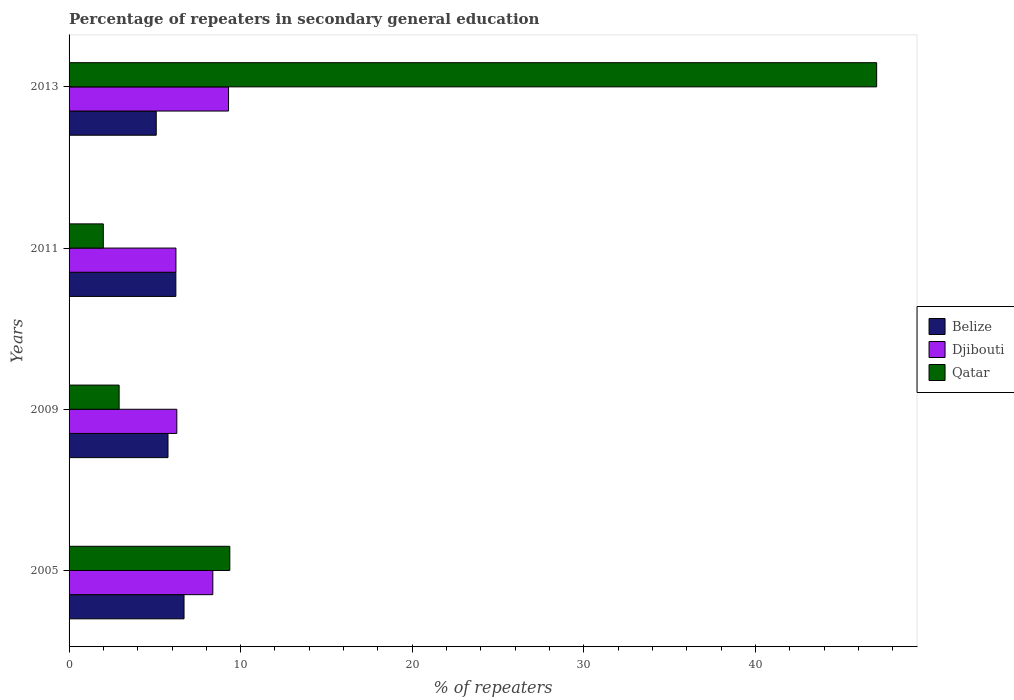How many groups of bars are there?
Your response must be concise. 4. Are the number of bars on each tick of the Y-axis equal?
Give a very brief answer. Yes. How many bars are there on the 1st tick from the bottom?
Offer a very short reply. 3. What is the percentage of repeaters in secondary general education in Belize in 2011?
Your answer should be compact. 6.22. Across all years, what is the maximum percentage of repeaters in secondary general education in Belize?
Provide a succinct answer. 6.7. Across all years, what is the minimum percentage of repeaters in secondary general education in Qatar?
Provide a succinct answer. 1.99. In which year was the percentage of repeaters in secondary general education in Qatar maximum?
Offer a terse response. 2013. In which year was the percentage of repeaters in secondary general education in Belize minimum?
Offer a very short reply. 2013. What is the total percentage of repeaters in secondary general education in Djibouti in the graph?
Your answer should be compact. 30.18. What is the difference between the percentage of repeaters in secondary general education in Djibouti in 2005 and that in 2011?
Your answer should be very brief. 2.15. What is the difference between the percentage of repeaters in secondary general education in Belize in 2011 and the percentage of repeaters in secondary general education in Qatar in 2013?
Provide a short and direct response. -40.84. What is the average percentage of repeaters in secondary general education in Qatar per year?
Your answer should be very brief. 15.34. In the year 2009, what is the difference between the percentage of repeaters in secondary general education in Qatar and percentage of repeaters in secondary general education in Djibouti?
Your response must be concise. -3.36. In how many years, is the percentage of repeaters in secondary general education in Qatar greater than 14 %?
Your response must be concise. 1. What is the ratio of the percentage of repeaters in secondary general education in Djibouti in 2011 to that in 2013?
Give a very brief answer. 0.67. What is the difference between the highest and the second highest percentage of repeaters in secondary general education in Belize?
Keep it short and to the point. 0.48. What is the difference between the highest and the lowest percentage of repeaters in secondary general education in Belize?
Provide a succinct answer. 1.62. What does the 3rd bar from the top in 2013 represents?
Provide a short and direct response. Belize. What does the 2nd bar from the bottom in 2011 represents?
Your answer should be compact. Djibouti. Is it the case that in every year, the sum of the percentage of repeaters in secondary general education in Belize and percentage of repeaters in secondary general education in Qatar is greater than the percentage of repeaters in secondary general education in Djibouti?
Provide a short and direct response. Yes. How many years are there in the graph?
Your response must be concise. 4. Does the graph contain any zero values?
Offer a very short reply. No. What is the title of the graph?
Your answer should be very brief. Percentage of repeaters in secondary general education. What is the label or title of the X-axis?
Your response must be concise. % of repeaters. What is the label or title of the Y-axis?
Provide a short and direct response. Years. What is the % of repeaters in Belize in 2005?
Give a very brief answer. 6.7. What is the % of repeaters of Djibouti in 2005?
Your answer should be very brief. 8.38. What is the % of repeaters in Qatar in 2005?
Provide a short and direct response. 9.37. What is the % of repeaters of Belize in 2009?
Your response must be concise. 5.77. What is the % of repeaters of Djibouti in 2009?
Give a very brief answer. 6.28. What is the % of repeaters in Qatar in 2009?
Your response must be concise. 2.92. What is the % of repeaters in Belize in 2011?
Your answer should be very brief. 6.22. What is the % of repeaters in Djibouti in 2011?
Your answer should be very brief. 6.23. What is the % of repeaters of Qatar in 2011?
Make the answer very short. 1.99. What is the % of repeaters in Belize in 2013?
Provide a short and direct response. 5.08. What is the % of repeaters in Djibouti in 2013?
Provide a short and direct response. 9.29. What is the % of repeaters in Qatar in 2013?
Ensure brevity in your answer.  47.07. Across all years, what is the maximum % of repeaters of Belize?
Keep it short and to the point. 6.7. Across all years, what is the maximum % of repeaters of Djibouti?
Your answer should be compact. 9.29. Across all years, what is the maximum % of repeaters of Qatar?
Provide a short and direct response. 47.07. Across all years, what is the minimum % of repeaters in Belize?
Offer a very short reply. 5.08. Across all years, what is the minimum % of repeaters in Djibouti?
Offer a very short reply. 6.23. Across all years, what is the minimum % of repeaters in Qatar?
Give a very brief answer. 1.99. What is the total % of repeaters of Belize in the graph?
Your answer should be very brief. 23.77. What is the total % of repeaters in Djibouti in the graph?
Provide a short and direct response. 30.18. What is the total % of repeaters of Qatar in the graph?
Give a very brief answer. 61.35. What is the difference between the % of repeaters of Belize in 2005 and that in 2009?
Ensure brevity in your answer.  0.93. What is the difference between the % of repeaters of Djibouti in 2005 and that in 2009?
Your answer should be compact. 2.1. What is the difference between the % of repeaters of Qatar in 2005 and that in 2009?
Your answer should be very brief. 6.45. What is the difference between the % of repeaters in Belize in 2005 and that in 2011?
Provide a short and direct response. 0.48. What is the difference between the % of repeaters of Djibouti in 2005 and that in 2011?
Make the answer very short. 2.15. What is the difference between the % of repeaters of Qatar in 2005 and that in 2011?
Your answer should be compact. 7.37. What is the difference between the % of repeaters of Belize in 2005 and that in 2013?
Provide a short and direct response. 1.62. What is the difference between the % of repeaters of Djibouti in 2005 and that in 2013?
Provide a succinct answer. -0.92. What is the difference between the % of repeaters in Qatar in 2005 and that in 2013?
Make the answer very short. -37.7. What is the difference between the % of repeaters of Belize in 2009 and that in 2011?
Keep it short and to the point. -0.46. What is the difference between the % of repeaters in Djibouti in 2009 and that in 2011?
Keep it short and to the point. 0.05. What is the difference between the % of repeaters of Qatar in 2009 and that in 2011?
Ensure brevity in your answer.  0.92. What is the difference between the % of repeaters in Belize in 2009 and that in 2013?
Keep it short and to the point. 0.69. What is the difference between the % of repeaters in Djibouti in 2009 and that in 2013?
Provide a short and direct response. -3.01. What is the difference between the % of repeaters of Qatar in 2009 and that in 2013?
Offer a very short reply. -44.15. What is the difference between the % of repeaters in Belize in 2011 and that in 2013?
Give a very brief answer. 1.14. What is the difference between the % of repeaters of Djibouti in 2011 and that in 2013?
Provide a short and direct response. -3.07. What is the difference between the % of repeaters of Qatar in 2011 and that in 2013?
Offer a very short reply. -45.07. What is the difference between the % of repeaters in Belize in 2005 and the % of repeaters in Djibouti in 2009?
Your answer should be compact. 0.42. What is the difference between the % of repeaters in Belize in 2005 and the % of repeaters in Qatar in 2009?
Keep it short and to the point. 3.78. What is the difference between the % of repeaters in Djibouti in 2005 and the % of repeaters in Qatar in 2009?
Offer a terse response. 5.46. What is the difference between the % of repeaters in Belize in 2005 and the % of repeaters in Djibouti in 2011?
Offer a terse response. 0.47. What is the difference between the % of repeaters in Belize in 2005 and the % of repeaters in Qatar in 2011?
Your answer should be compact. 4.71. What is the difference between the % of repeaters of Djibouti in 2005 and the % of repeaters of Qatar in 2011?
Ensure brevity in your answer.  6.38. What is the difference between the % of repeaters in Belize in 2005 and the % of repeaters in Djibouti in 2013?
Offer a very short reply. -2.59. What is the difference between the % of repeaters of Belize in 2005 and the % of repeaters of Qatar in 2013?
Provide a succinct answer. -40.37. What is the difference between the % of repeaters of Djibouti in 2005 and the % of repeaters of Qatar in 2013?
Give a very brief answer. -38.69. What is the difference between the % of repeaters of Belize in 2009 and the % of repeaters of Djibouti in 2011?
Offer a terse response. -0.46. What is the difference between the % of repeaters in Belize in 2009 and the % of repeaters in Qatar in 2011?
Offer a terse response. 3.77. What is the difference between the % of repeaters of Djibouti in 2009 and the % of repeaters of Qatar in 2011?
Keep it short and to the point. 4.29. What is the difference between the % of repeaters in Belize in 2009 and the % of repeaters in Djibouti in 2013?
Provide a short and direct response. -3.53. What is the difference between the % of repeaters in Belize in 2009 and the % of repeaters in Qatar in 2013?
Keep it short and to the point. -41.3. What is the difference between the % of repeaters in Djibouti in 2009 and the % of repeaters in Qatar in 2013?
Provide a short and direct response. -40.79. What is the difference between the % of repeaters of Belize in 2011 and the % of repeaters of Djibouti in 2013?
Ensure brevity in your answer.  -3.07. What is the difference between the % of repeaters in Belize in 2011 and the % of repeaters in Qatar in 2013?
Keep it short and to the point. -40.84. What is the difference between the % of repeaters in Djibouti in 2011 and the % of repeaters in Qatar in 2013?
Make the answer very short. -40.84. What is the average % of repeaters of Belize per year?
Ensure brevity in your answer.  5.94. What is the average % of repeaters in Djibouti per year?
Provide a short and direct response. 7.55. What is the average % of repeaters of Qatar per year?
Offer a very short reply. 15.34. In the year 2005, what is the difference between the % of repeaters in Belize and % of repeaters in Djibouti?
Give a very brief answer. -1.68. In the year 2005, what is the difference between the % of repeaters of Belize and % of repeaters of Qatar?
Provide a short and direct response. -2.67. In the year 2005, what is the difference between the % of repeaters of Djibouti and % of repeaters of Qatar?
Provide a short and direct response. -0.99. In the year 2009, what is the difference between the % of repeaters of Belize and % of repeaters of Djibouti?
Your answer should be very brief. -0.51. In the year 2009, what is the difference between the % of repeaters of Belize and % of repeaters of Qatar?
Ensure brevity in your answer.  2.85. In the year 2009, what is the difference between the % of repeaters of Djibouti and % of repeaters of Qatar?
Your response must be concise. 3.36. In the year 2011, what is the difference between the % of repeaters of Belize and % of repeaters of Djibouti?
Your response must be concise. -0. In the year 2011, what is the difference between the % of repeaters of Belize and % of repeaters of Qatar?
Your answer should be very brief. 4.23. In the year 2011, what is the difference between the % of repeaters of Djibouti and % of repeaters of Qatar?
Your response must be concise. 4.23. In the year 2013, what is the difference between the % of repeaters in Belize and % of repeaters in Djibouti?
Your answer should be very brief. -4.21. In the year 2013, what is the difference between the % of repeaters of Belize and % of repeaters of Qatar?
Provide a succinct answer. -41.99. In the year 2013, what is the difference between the % of repeaters of Djibouti and % of repeaters of Qatar?
Provide a short and direct response. -37.77. What is the ratio of the % of repeaters in Belize in 2005 to that in 2009?
Offer a very short reply. 1.16. What is the ratio of the % of repeaters of Djibouti in 2005 to that in 2009?
Provide a short and direct response. 1.33. What is the ratio of the % of repeaters of Qatar in 2005 to that in 2009?
Give a very brief answer. 3.21. What is the ratio of the % of repeaters in Belize in 2005 to that in 2011?
Give a very brief answer. 1.08. What is the ratio of the % of repeaters of Djibouti in 2005 to that in 2011?
Give a very brief answer. 1.35. What is the ratio of the % of repeaters in Qatar in 2005 to that in 2011?
Make the answer very short. 4.7. What is the ratio of the % of repeaters in Belize in 2005 to that in 2013?
Keep it short and to the point. 1.32. What is the ratio of the % of repeaters of Djibouti in 2005 to that in 2013?
Ensure brevity in your answer.  0.9. What is the ratio of the % of repeaters in Qatar in 2005 to that in 2013?
Your response must be concise. 0.2. What is the ratio of the % of repeaters of Belize in 2009 to that in 2011?
Make the answer very short. 0.93. What is the ratio of the % of repeaters in Djibouti in 2009 to that in 2011?
Keep it short and to the point. 1.01. What is the ratio of the % of repeaters in Qatar in 2009 to that in 2011?
Your answer should be compact. 1.46. What is the ratio of the % of repeaters in Belize in 2009 to that in 2013?
Give a very brief answer. 1.14. What is the ratio of the % of repeaters of Djibouti in 2009 to that in 2013?
Your answer should be compact. 0.68. What is the ratio of the % of repeaters of Qatar in 2009 to that in 2013?
Make the answer very short. 0.06. What is the ratio of the % of repeaters in Belize in 2011 to that in 2013?
Provide a short and direct response. 1.23. What is the ratio of the % of repeaters in Djibouti in 2011 to that in 2013?
Ensure brevity in your answer.  0.67. What is the ratio of the % of repeaters in Qatar in 2011 to that in 2013?
Offer a terse response. 0.04. What is the difference between the highest and the second highest % of repeaters in Belize?
Provide a succinct answer. 0.48. What is the difference between the highest and the second highest % of repeaters in Djibouti?
Make the answer very short. 0.92. What is the difference between the highest and the second highest % of repeaters of Qatar?
Give a very brief answer. 37.7. What is the difference between the highest and the lowest % of repeaters of Belize?
Your answer should be compact. 1.62. What is the difference between the highest and the lowest % of repeaters of Djibouti?
Offer a terse response. 3.07. What is the difference between the highest and the lowest % of repeaters of Qatar?
Provide a succinct answer. 45.07. 